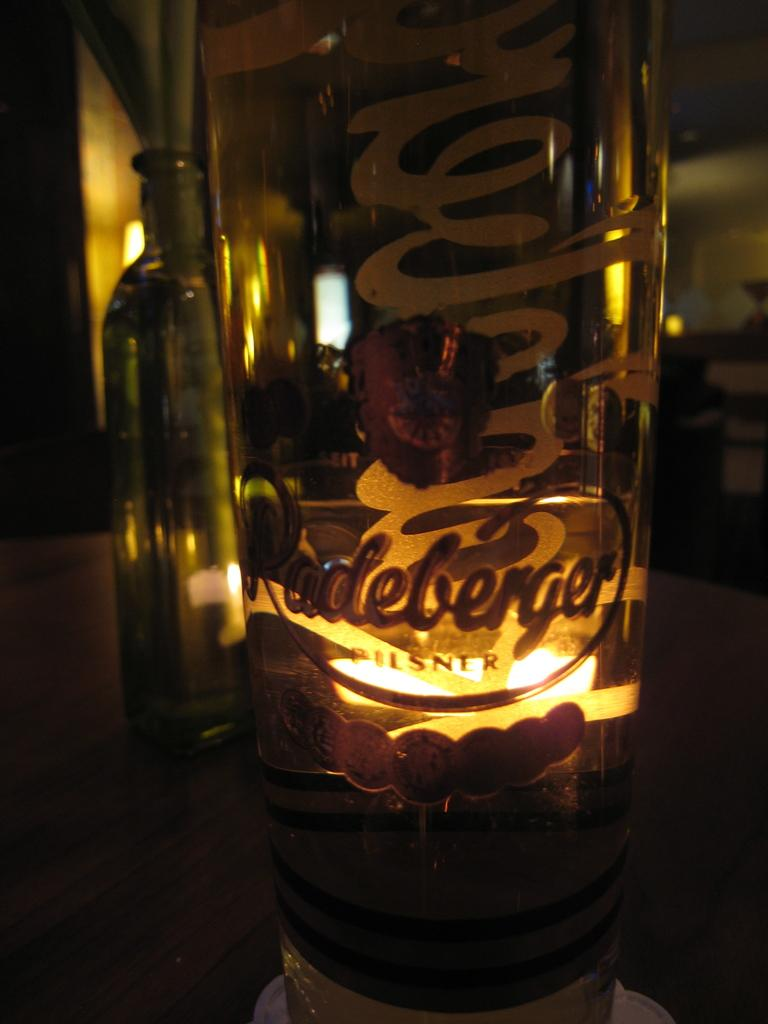What is the main object in the image? There is a glass bottle with a light in the image. Are there any other glass bottles in the image? Yes, there is another glass bottle in the background of the image. Where is the second glass bottle located? The second glass bottle is on a table. What type of pail is being used to carry the drum in the image? There is no pail or drum present in the image. 